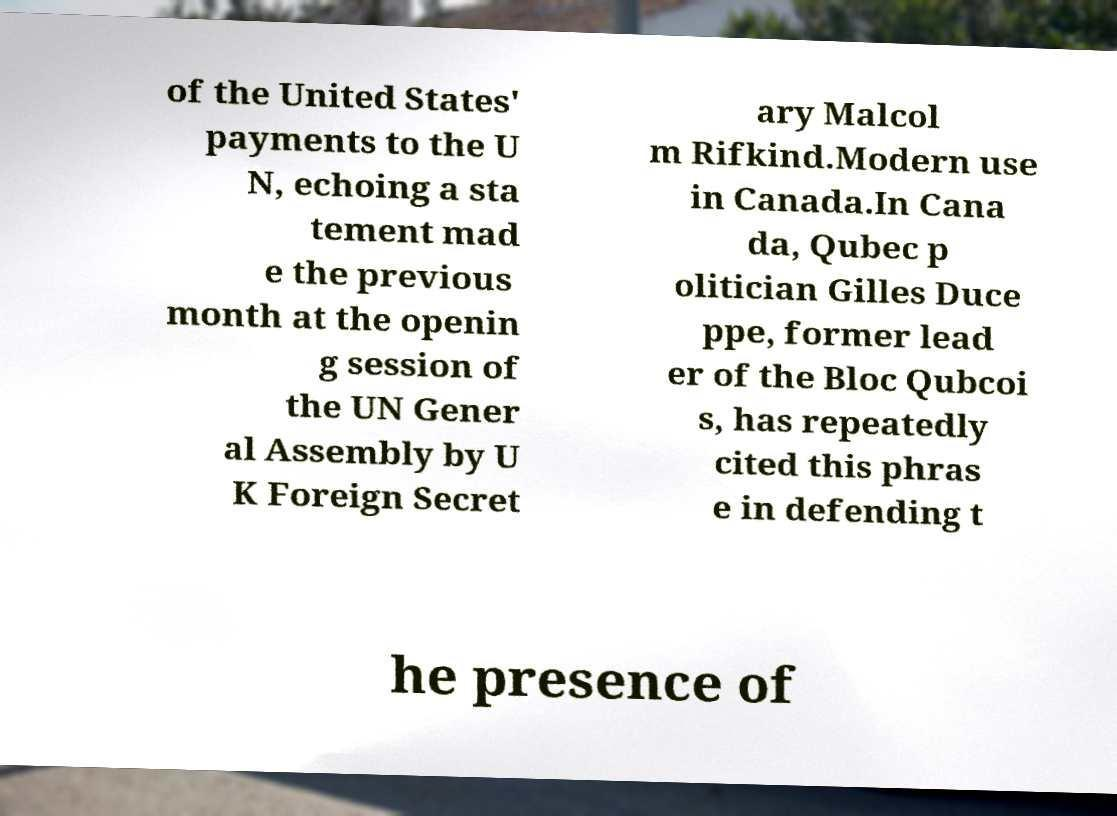For documentation purposes, I need the text within this image transcribed. Could you provide that? of the United States' payments to the U N, echoing a sta tement mad e the previous month at the openin g session of the UN Gener al Assembly by U K Foreign Secret ary Malcol m Rifkind.Modern use in Canada.In Cana da, Qubec p olitician Gilles Duce ppe, former lead er of the Bloc Qubcoi s, has repeatedly cited this phras e in defending t he presence of 